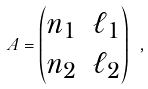Convert formula to latex. <formula><loc_0><loc_0><loc_500><loc_500>A = \begin{pmatrix} n _ { 1 } & \ell _ { 1 } \\ n _ { 2 } & \ell _ { 2 } \end{pmatrix} \ ,</formula> 